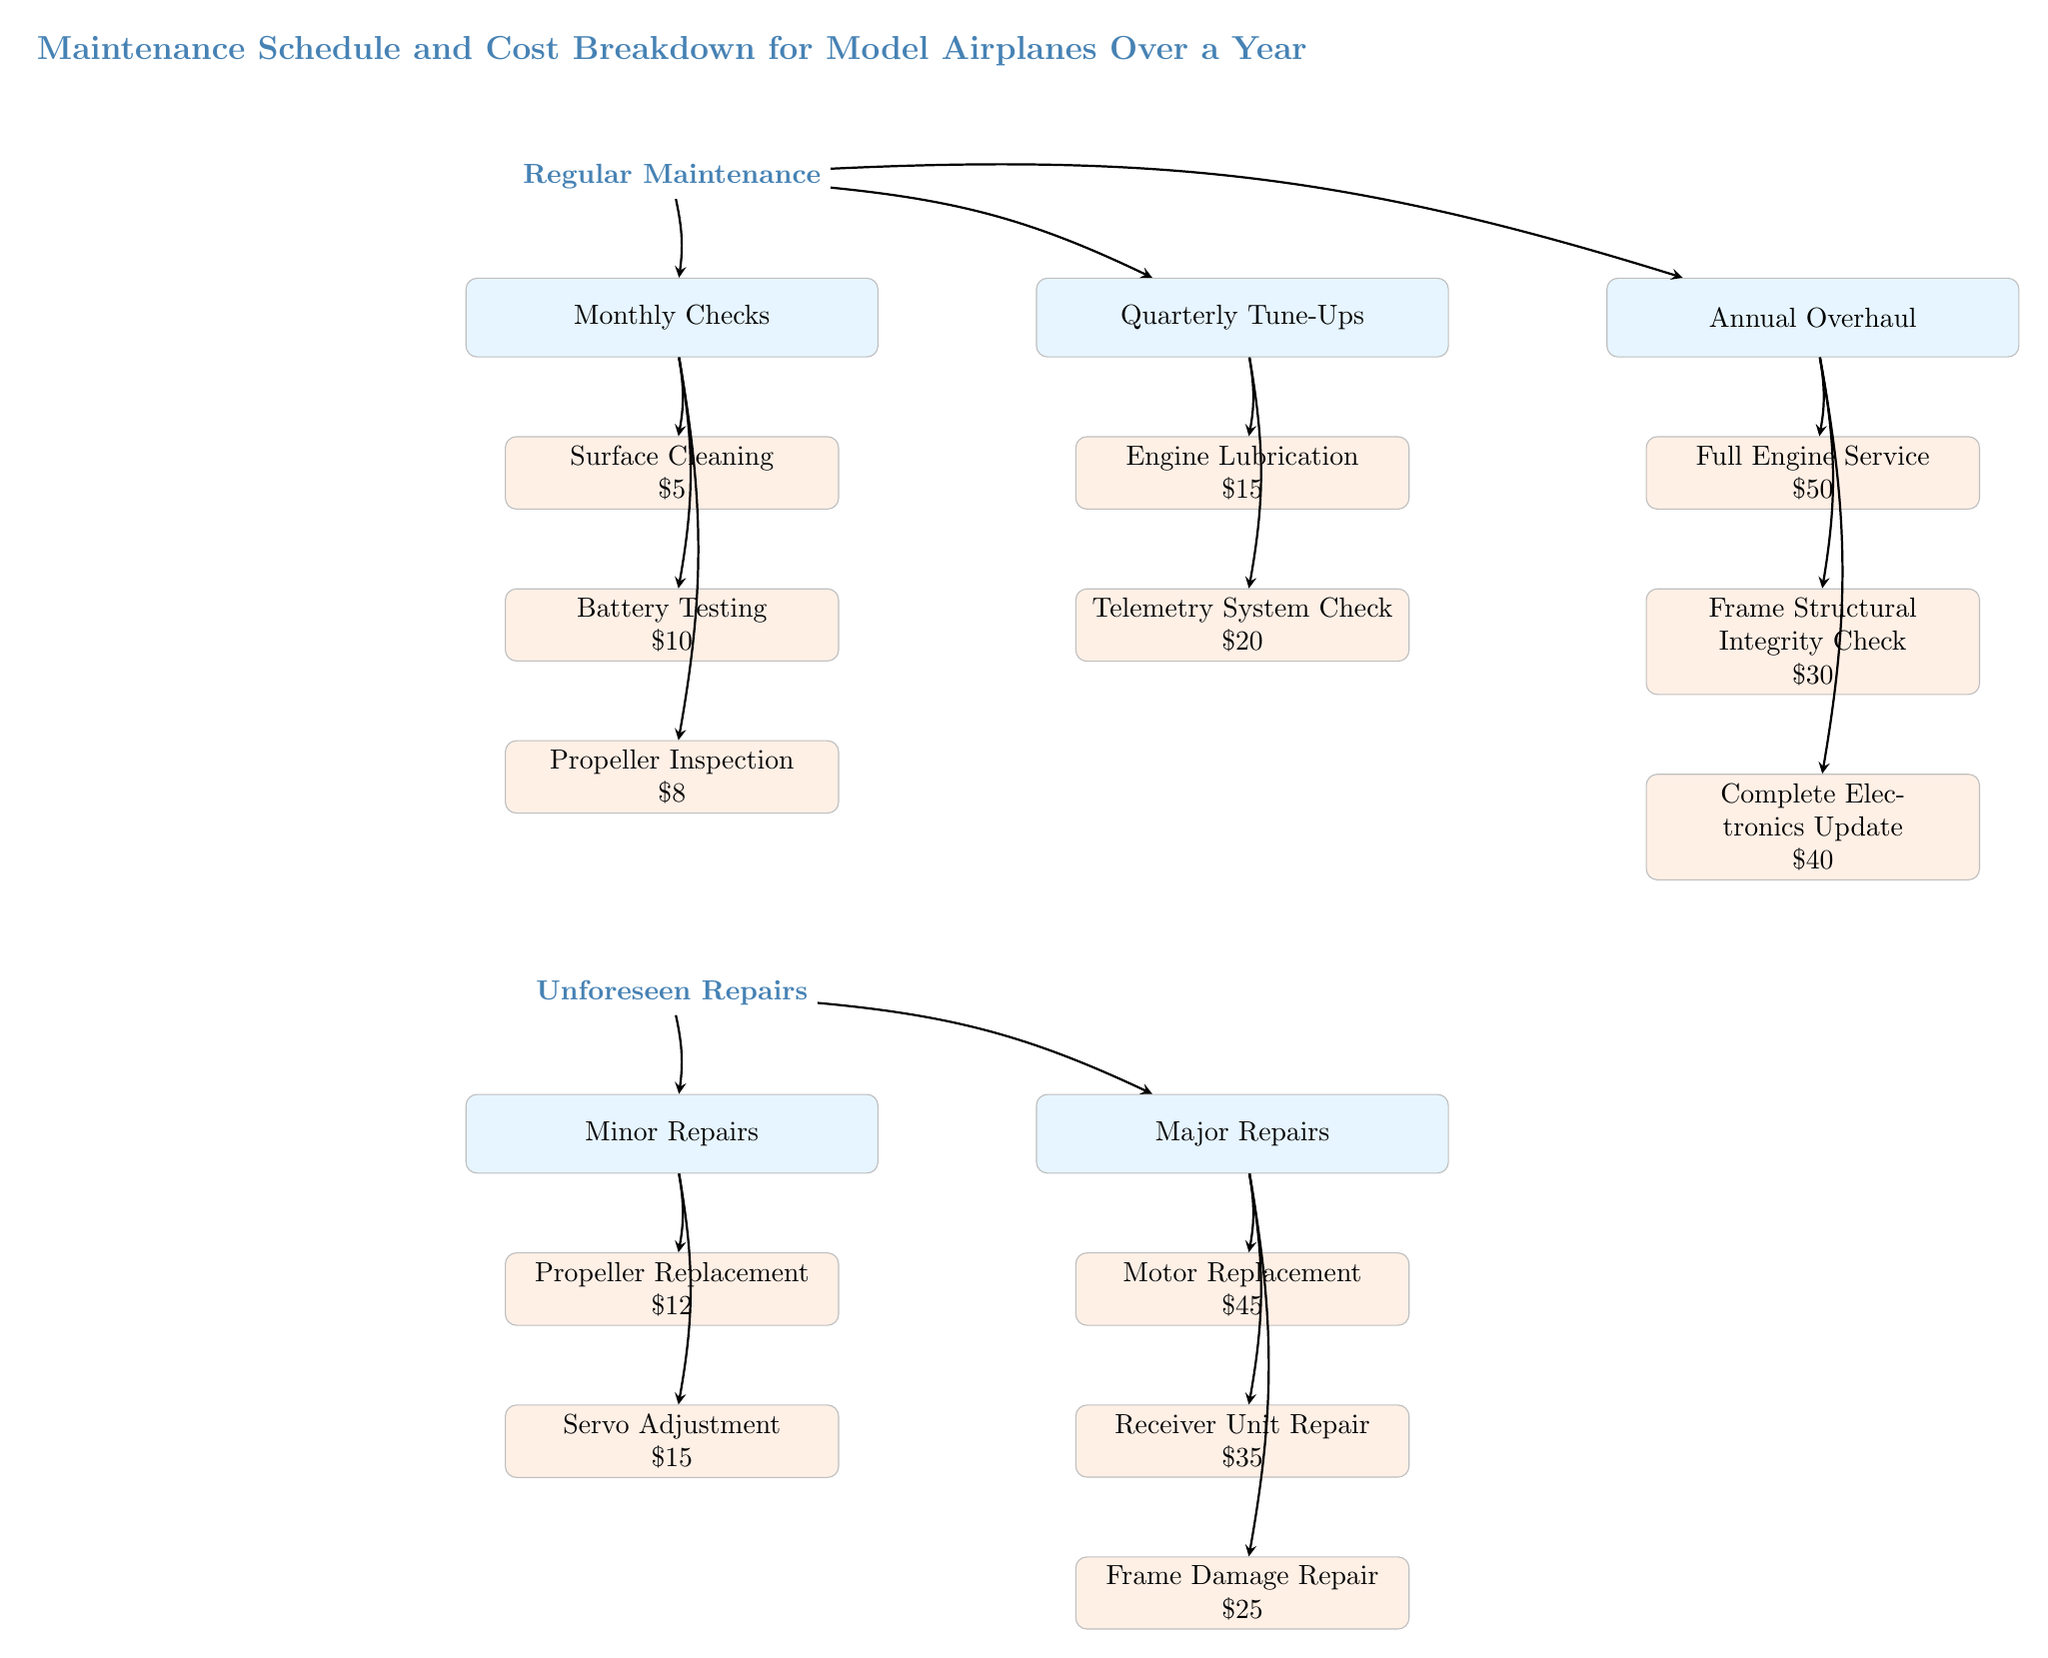What are the total costs for regular maintenance? To find the total costs for regular maintenance, we need to sum the costs from each section: Monthly Checks: $5 + $10 + $8 = $23, Quarterly Tune-Ups: $15 + $20 = $35, and Annual Overhaul: $50 + $30 + $40 = $120. Thus, the total costs for regular maintenance become $23 + $35 + $120 = $178.
Answer: 178 How many types of unforeseen repairs are listed? The diagram shows two categories under unforeseen repairs: Minor Repairs and Major Repairs. Within Minor Repairs, there are 2 types (Propeller Replacement and Servo Adjustment), and in Major Repairs, there are 3 types (Motor Replacement, Receiver Unit Repair, and Frame Damage Repair). Therefore, adding these gives us a total of 2 + 3 = 5 types of unforeseen repairs.
Answer: 5 What specific inspection is done monthly? The monthly checks include three items: Surface Cleaning, Battery Testing, and Propeller Inspection. Therefore, the specific inspection done monthly can refer to any of these, but the most emphasized inspection in a maintenance context is usually the Propeller Inspection.
Answer: Propeller Inspection Which section has the highest individual cost? Looking at the costs listed in each maintenance category: Full Engine Service at $50, Frame Structural Integrity Check at $30, Complete Electronics Update at $40 in Annual Overhaul; in Major Repairs, Motor Replacement at $45 is the highest. Thus, comparing these, the Full Engine Service at $50 holds the highest cost overall.
Answer: Full Engine Service What kind of repairs are grouped under Major Repairs? The Major Repairs section includes three types of repairs: Motor Replacement, Receiver Unit Repair, and Frame Damage Repair. These repairs typically involve significant costs and effort compared to minor repairs. Thus, they are grouped under Major Repairs.
Answer: Motor Replacement, Receiver Unit Repair, Frame Damage Repair What is the frequency of the Quarterly Tune-Ups? The Quarterly Tune-Ups occur four times a year, as indicated by the title that contains the word "Quarterly." Each occurrence includes tasks such as Engine Lubrication and Telemetry System Check. Therefore, the frequency is clearly defined as quarterly.
Answer: Quarterly What is the total cost of minor repairs? To find the total cost of minor repairs, we add up Propeller Replacement at $12 and Servo Adjustment at $15: $12 + $15 = $27. Therefore, the total cost for minor repairs is $27.
Answer: 27 What is the maintenance task associated with battery? The task associated with the battery in the regular maintenance schedule is Battery Testing, which costs $10. This task ensures the batteries of the model airplanes are functioning properly.
Answer: Battery Testing 